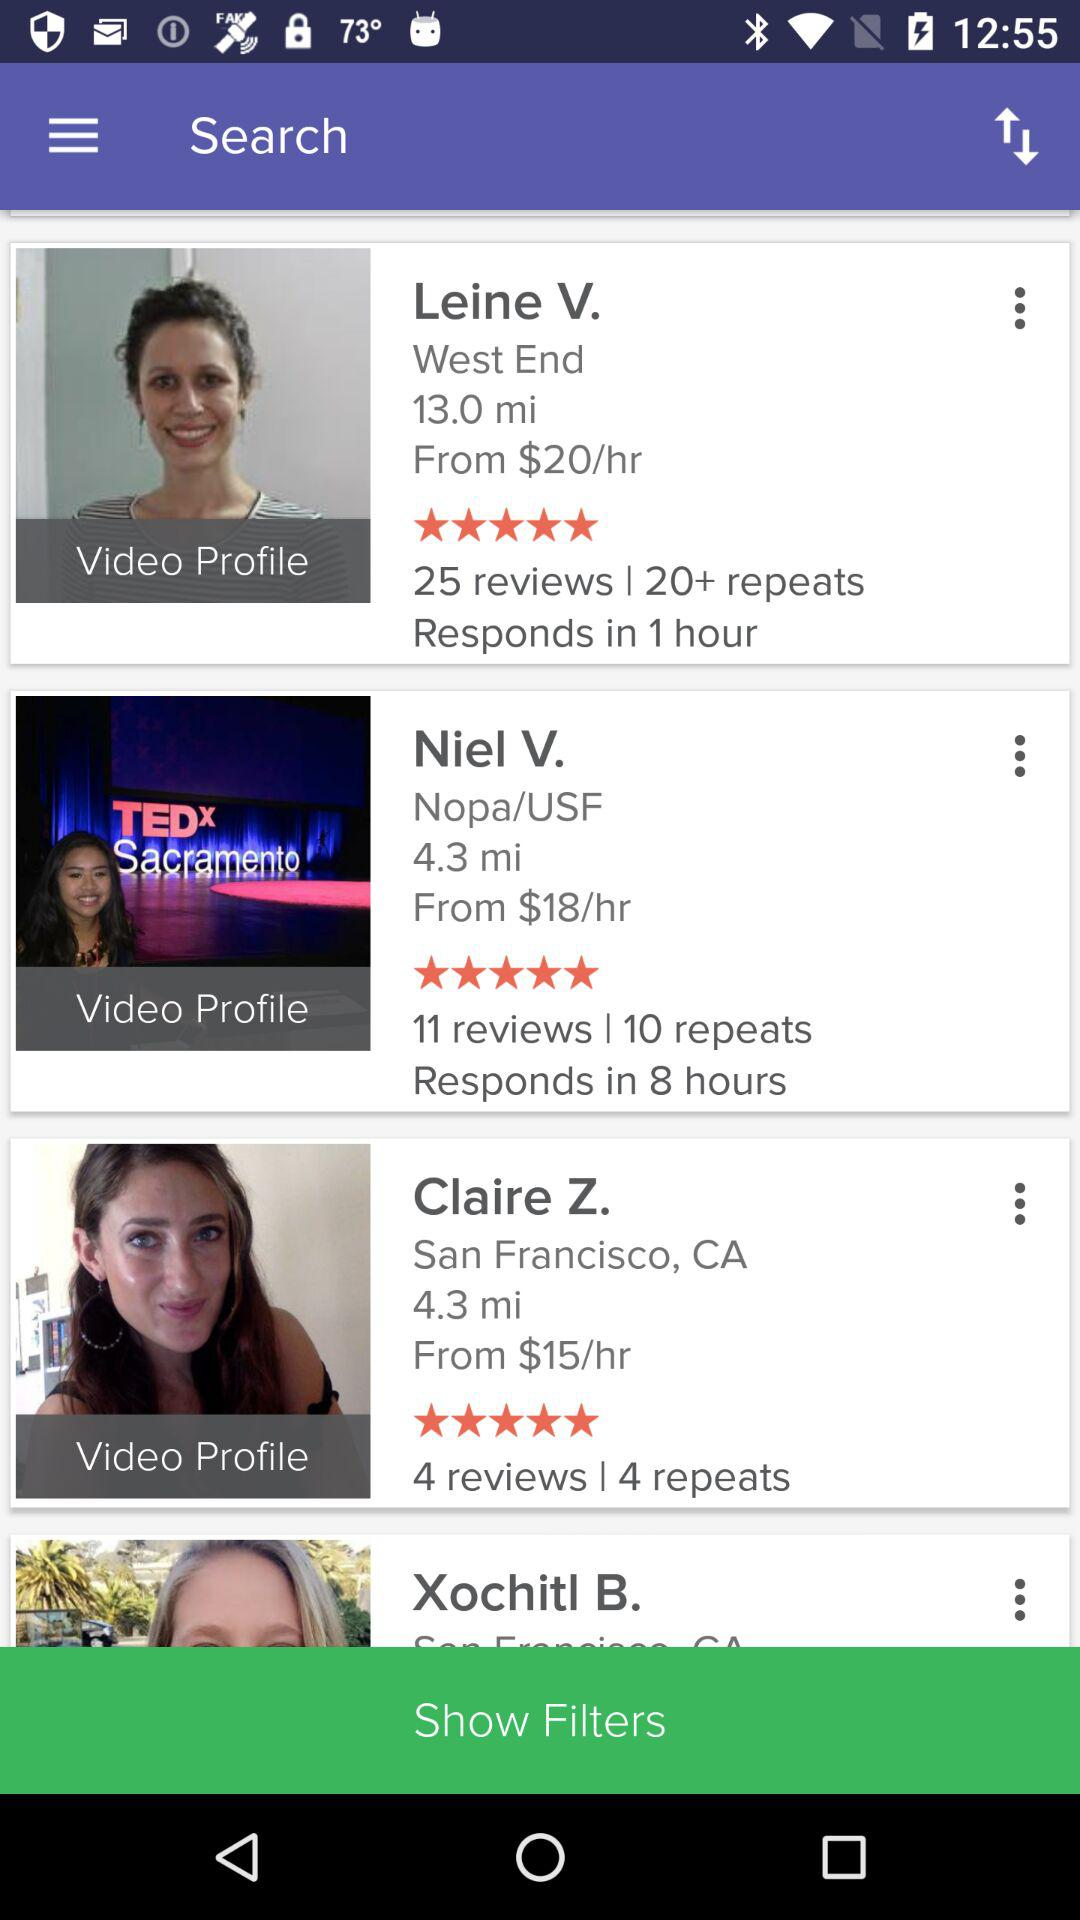What is the number of reviews for Leine V.? There are 25 reviews for Leine V. 